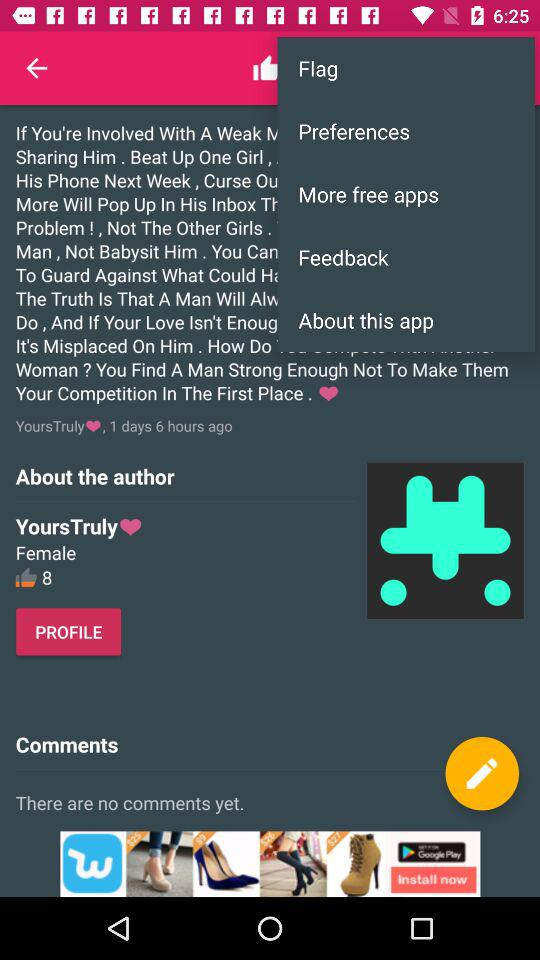How many comments are there? There are no comments. 